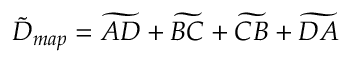<formula> <loc_0><loc_0><loc_500><loc_500>\tilde { D } _ { m a p } = \widetilde { A D } + \widetilde { B C } + \widetilde { C B } + \widetilde { D A }</formula> 